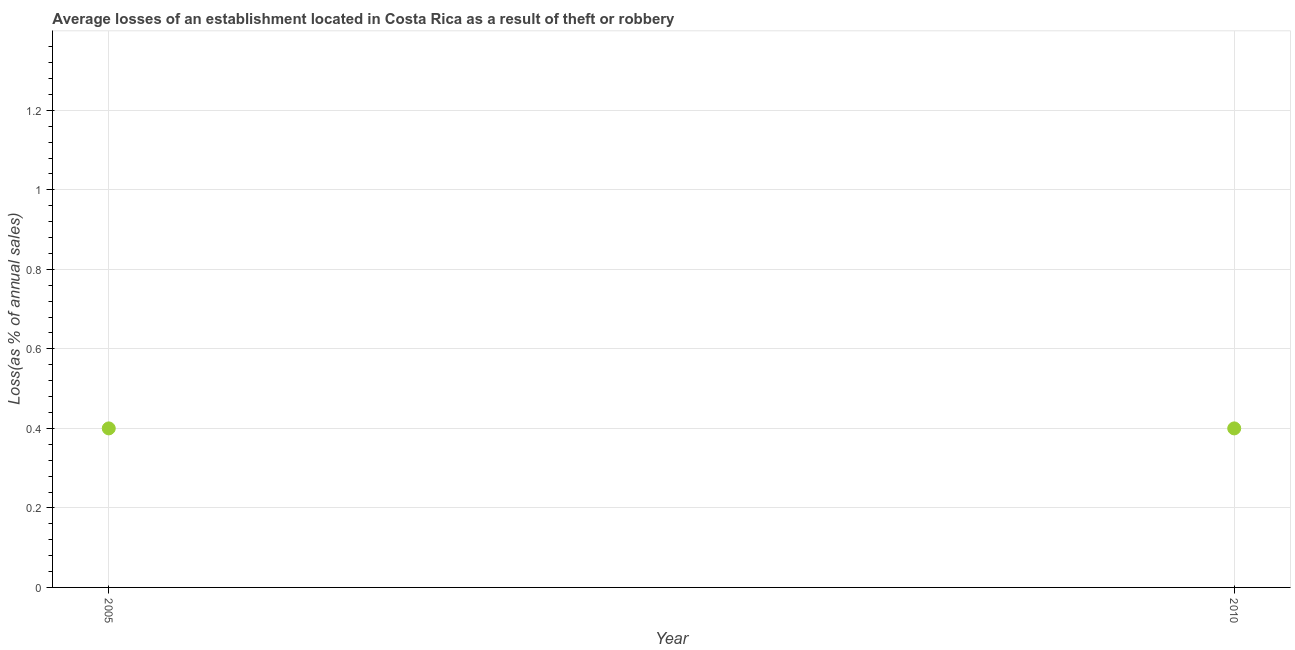What is the losses due to theft in 2005?
Offer a terse response. 0.4. Across all years, what is the minimum losses due to theft?
Make the answer very short. 0.4. In which year was the losses due to theft maximum?
Give a very brief answer. 2005. What is the average losses due to theft per year?
Your answer should be very brief. 0.4. In how many years, is the losses due to theft greater than 0.68 %?
Provide a short and direct response. 0. What is the ratio of the losses due to theft in 2005 to that in 2010?
Ensure brevity in your answer.  1. Is the losses due to theft in 2005 less than that in 2010?
Keep it short and to the point. No. Does the losses due to theft monotonically increase over the years?
Provide a succinct answer. No. What is the title of the graph?
Your answer should be compact. Average losses of an establishment located in Costa Rica as a result of theft or robbery. What is the label or title of the Y-axis?
Provide a succinct answer. Loss(as % of annual sales). What is the difference between the Loss(as % of annual sales) in 2005 and 2010?
Provide a succinct answer. 0. 